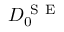Convert formula to latex. <formula><loc_0><loc_0><loc_500><loc_500>D _ { 0 } ^ { S E }</formula> 